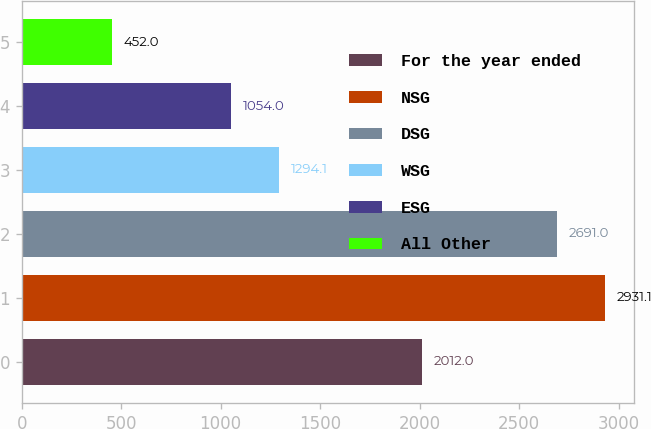<chart> <loc_0><loc_0><loc_500><loc_500><bar_chart><fcel>For the year ended<fcel>NSG<fcel>DSG<fcel>WSG<fcel>ESG<fcel>All Other<nl><fcel>2012<fcel>2931.1<fcel>2691<fcel>1294.1<fcel>1054<fcel>452<nl></chart> 